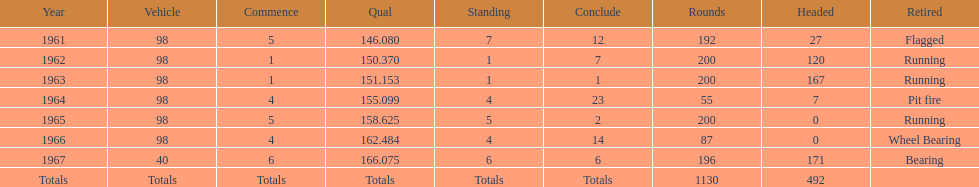In which years did he lead the race the least? 1965, 1966. 